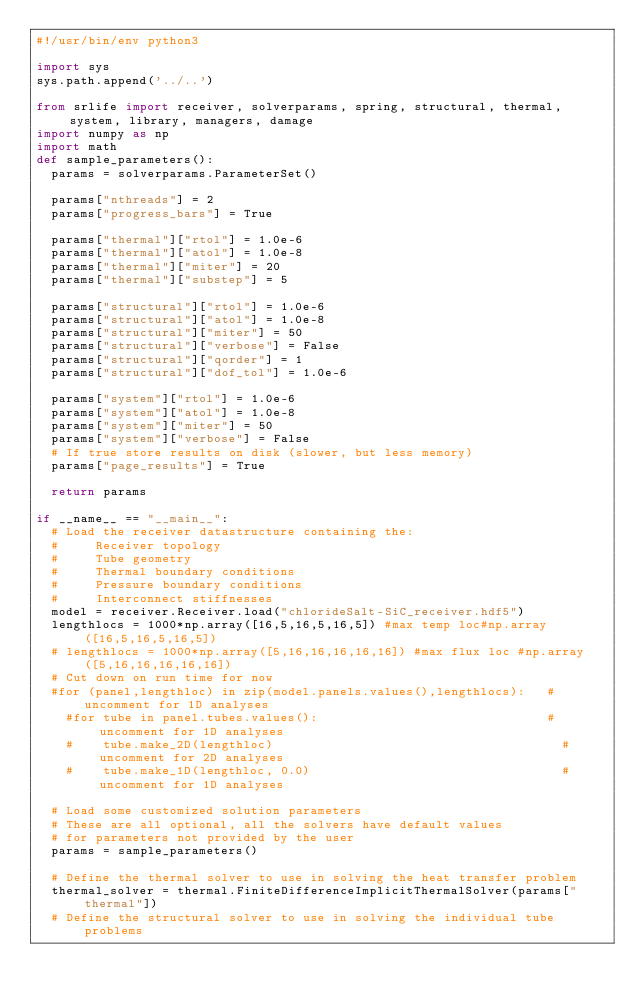Convert code to text. <code><loc_0><loc_0><loc_500><loc_500><_Python_>#!/usr/bin/env python3

import sys
sys.path.append('../..')

from srlife import receiver, solverparams, spring, structural, thermal, system, library, managers, damage
import numpy as np
import math
def sample_parameters():
  params = solverparams.ParameterSet()

  params["nthreads"] = 2
  params["progress_bars"] = True

  params["thermal"]["rtol"] = 1.0e-6
  params["thermal"]["atol"] = 1.0e-8
  params["thermal"]["miter"] = 20
  params["thermal"]["substep"] = 5

  params["structural"]["rtol"] = 1.0e-6
  params["structural"]["atol"] = 1.0e-8
  params["structural"]["miter"] = 50
  params["structural"]["verbose"] = False
  params["structural"]["qorder"] = 1
  params["structural"]["dof_tol"] = 1.0e-6

  params["system"]["rtol"] = 1.0e-6
  params["system"]["atol"] = 1.0e-8
  params["system"]["miter"] = 50
  params["system"]["verbose"] = False
  # If true store results on disk (slower, but less memory)
  params["page_results"] = True

  return params

if __name__ == "__main__":
  # Load the receiver datastructure containing the:
  #     Receiver topology
  #     Tube geometry
  #     Thermal boundary conditions
  #     Pressure boundary conditions
  #     Interconnect stiffnesses
  model = receiver.Receiver.load("chlorideSalt-SiC_receiver.hdf5")
  lengthlocs = 1000*np.array([16,5,16,5,16,5]) #max temp loc#np.array([16,5,16,5,16,5])
  # lengthlocs = 1000*np.array([5,16,16,16,16,16]) #max flux loc #np.array([5,16,16,16,16,16])
  # Cut down on run time for now
  #for (panel,lengthloc) in zip(model.panels.values(),lengthlocs):   # uncomment for 1D analyses
    #for tube in panel.tubes.values():                               # uncomment for 1D analyses
    #    tube.make_2D(lengthloc)                                       # uncomment for 2D analyses
    #    tube.make_1D(lengthloc, 0.0)                                  # uncomment for 1D analyses

  # Load some customized solution parameters
  # These are all optional, all the solvers have default values
  # for parameters not provided by the user
  params = sample_parameters()

  # Define the thermal solver to use in solving the heat transfer problem
  thermal_solver = thermal.FiniteDifferenceImplicitThermalSolver(params["thermal"])
  # Define the structural solver to use in solving the individual tube problems</code> 